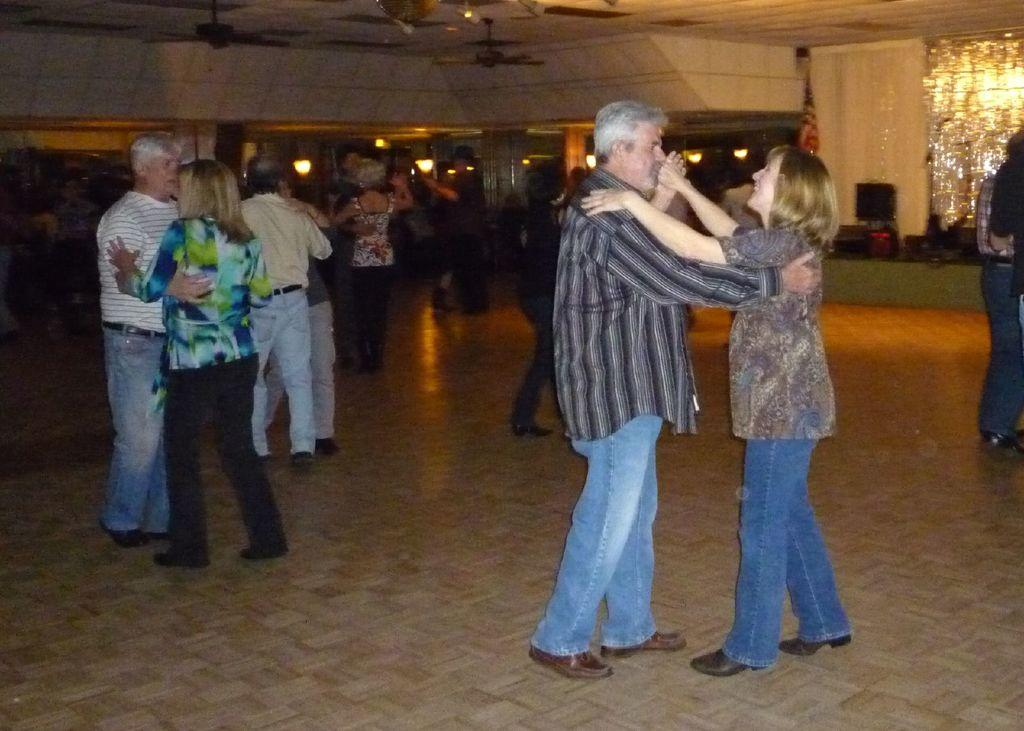What are the people in the image doing? The people in the image are dancing. Where are the people dancing? The people are dancing on the floor. What can be seen in the image that might be related to music or sound? There are speakers visible in the image. What is present in the image that might provide ventilation or cooling? There are fans attached to the roof in the image. What type of lace is being used to tie the dancers' shoes in the image? There is no mention of lace or shoes in the image; the focus is on the people dancing and the presence of speakers and fans. 